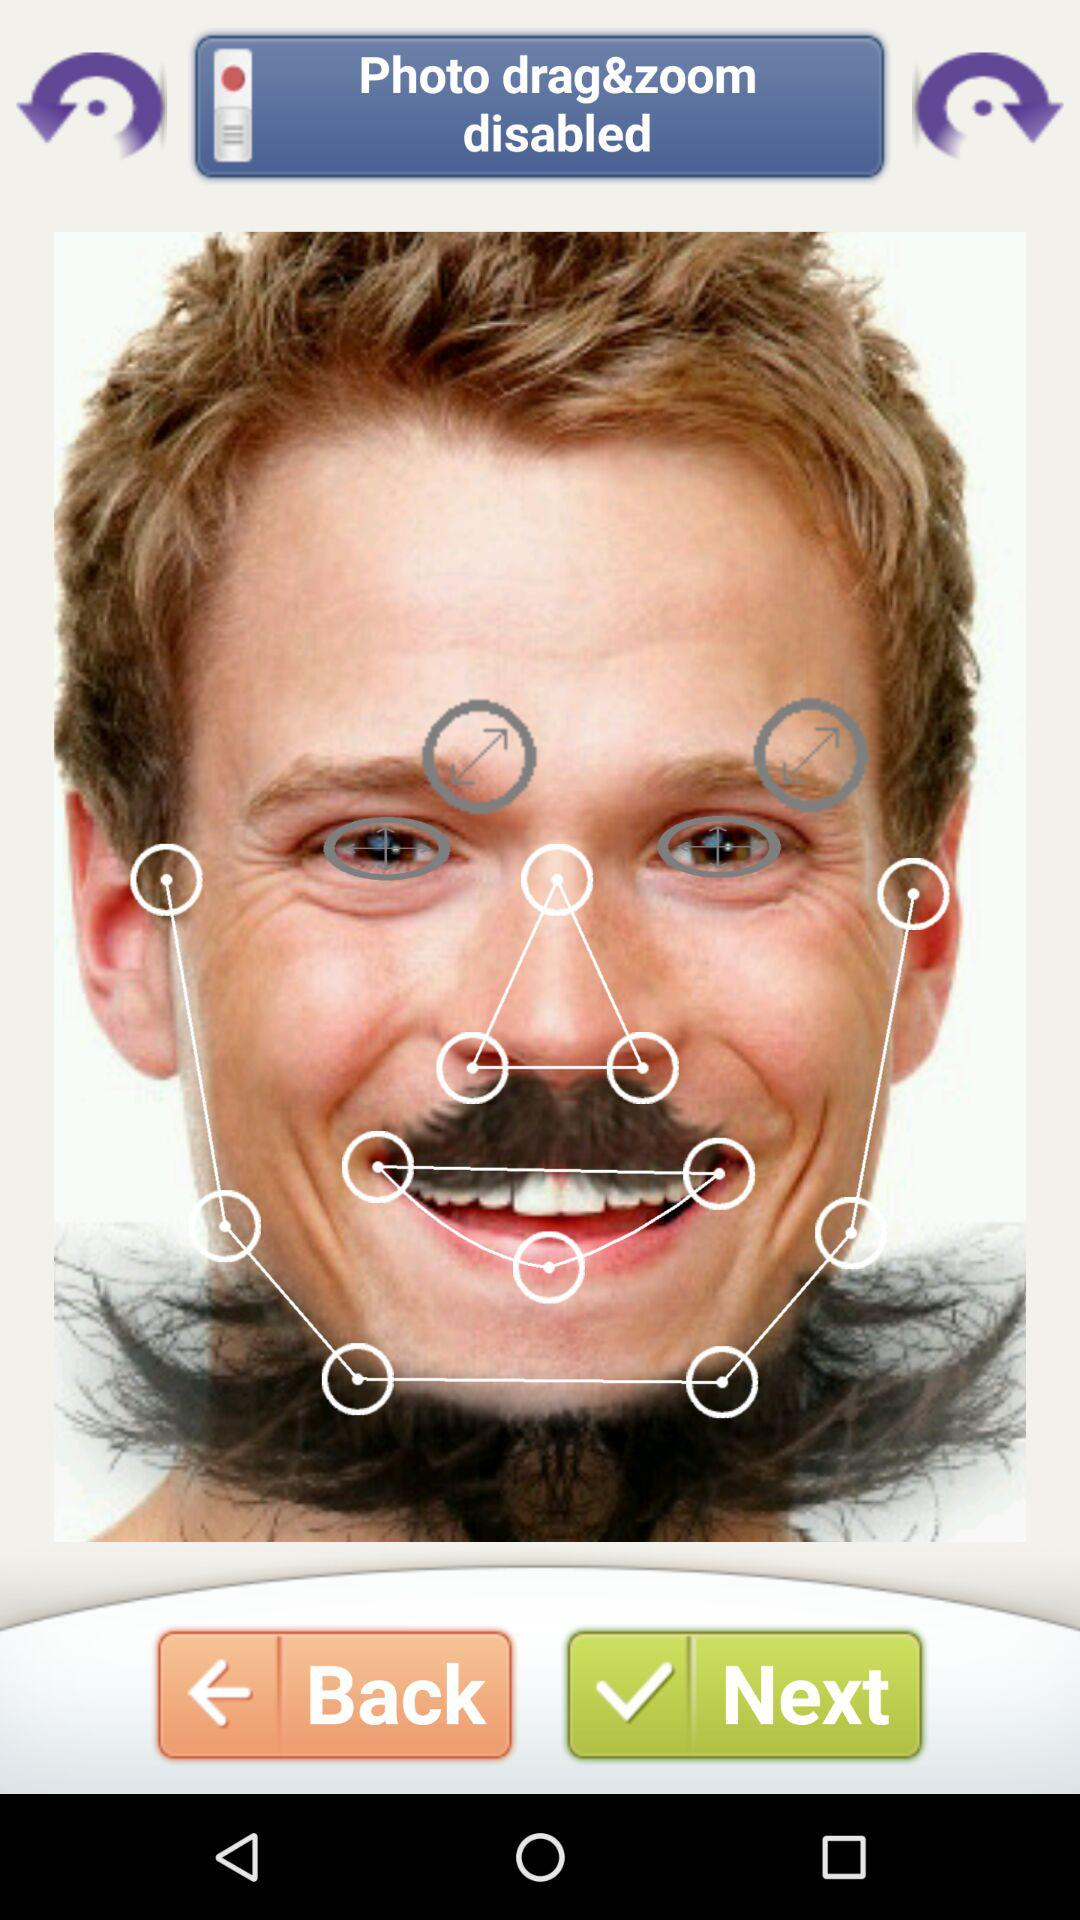What is the name of the application?
When the provided information is insufficient, respond with <no answer>. <no answer> 